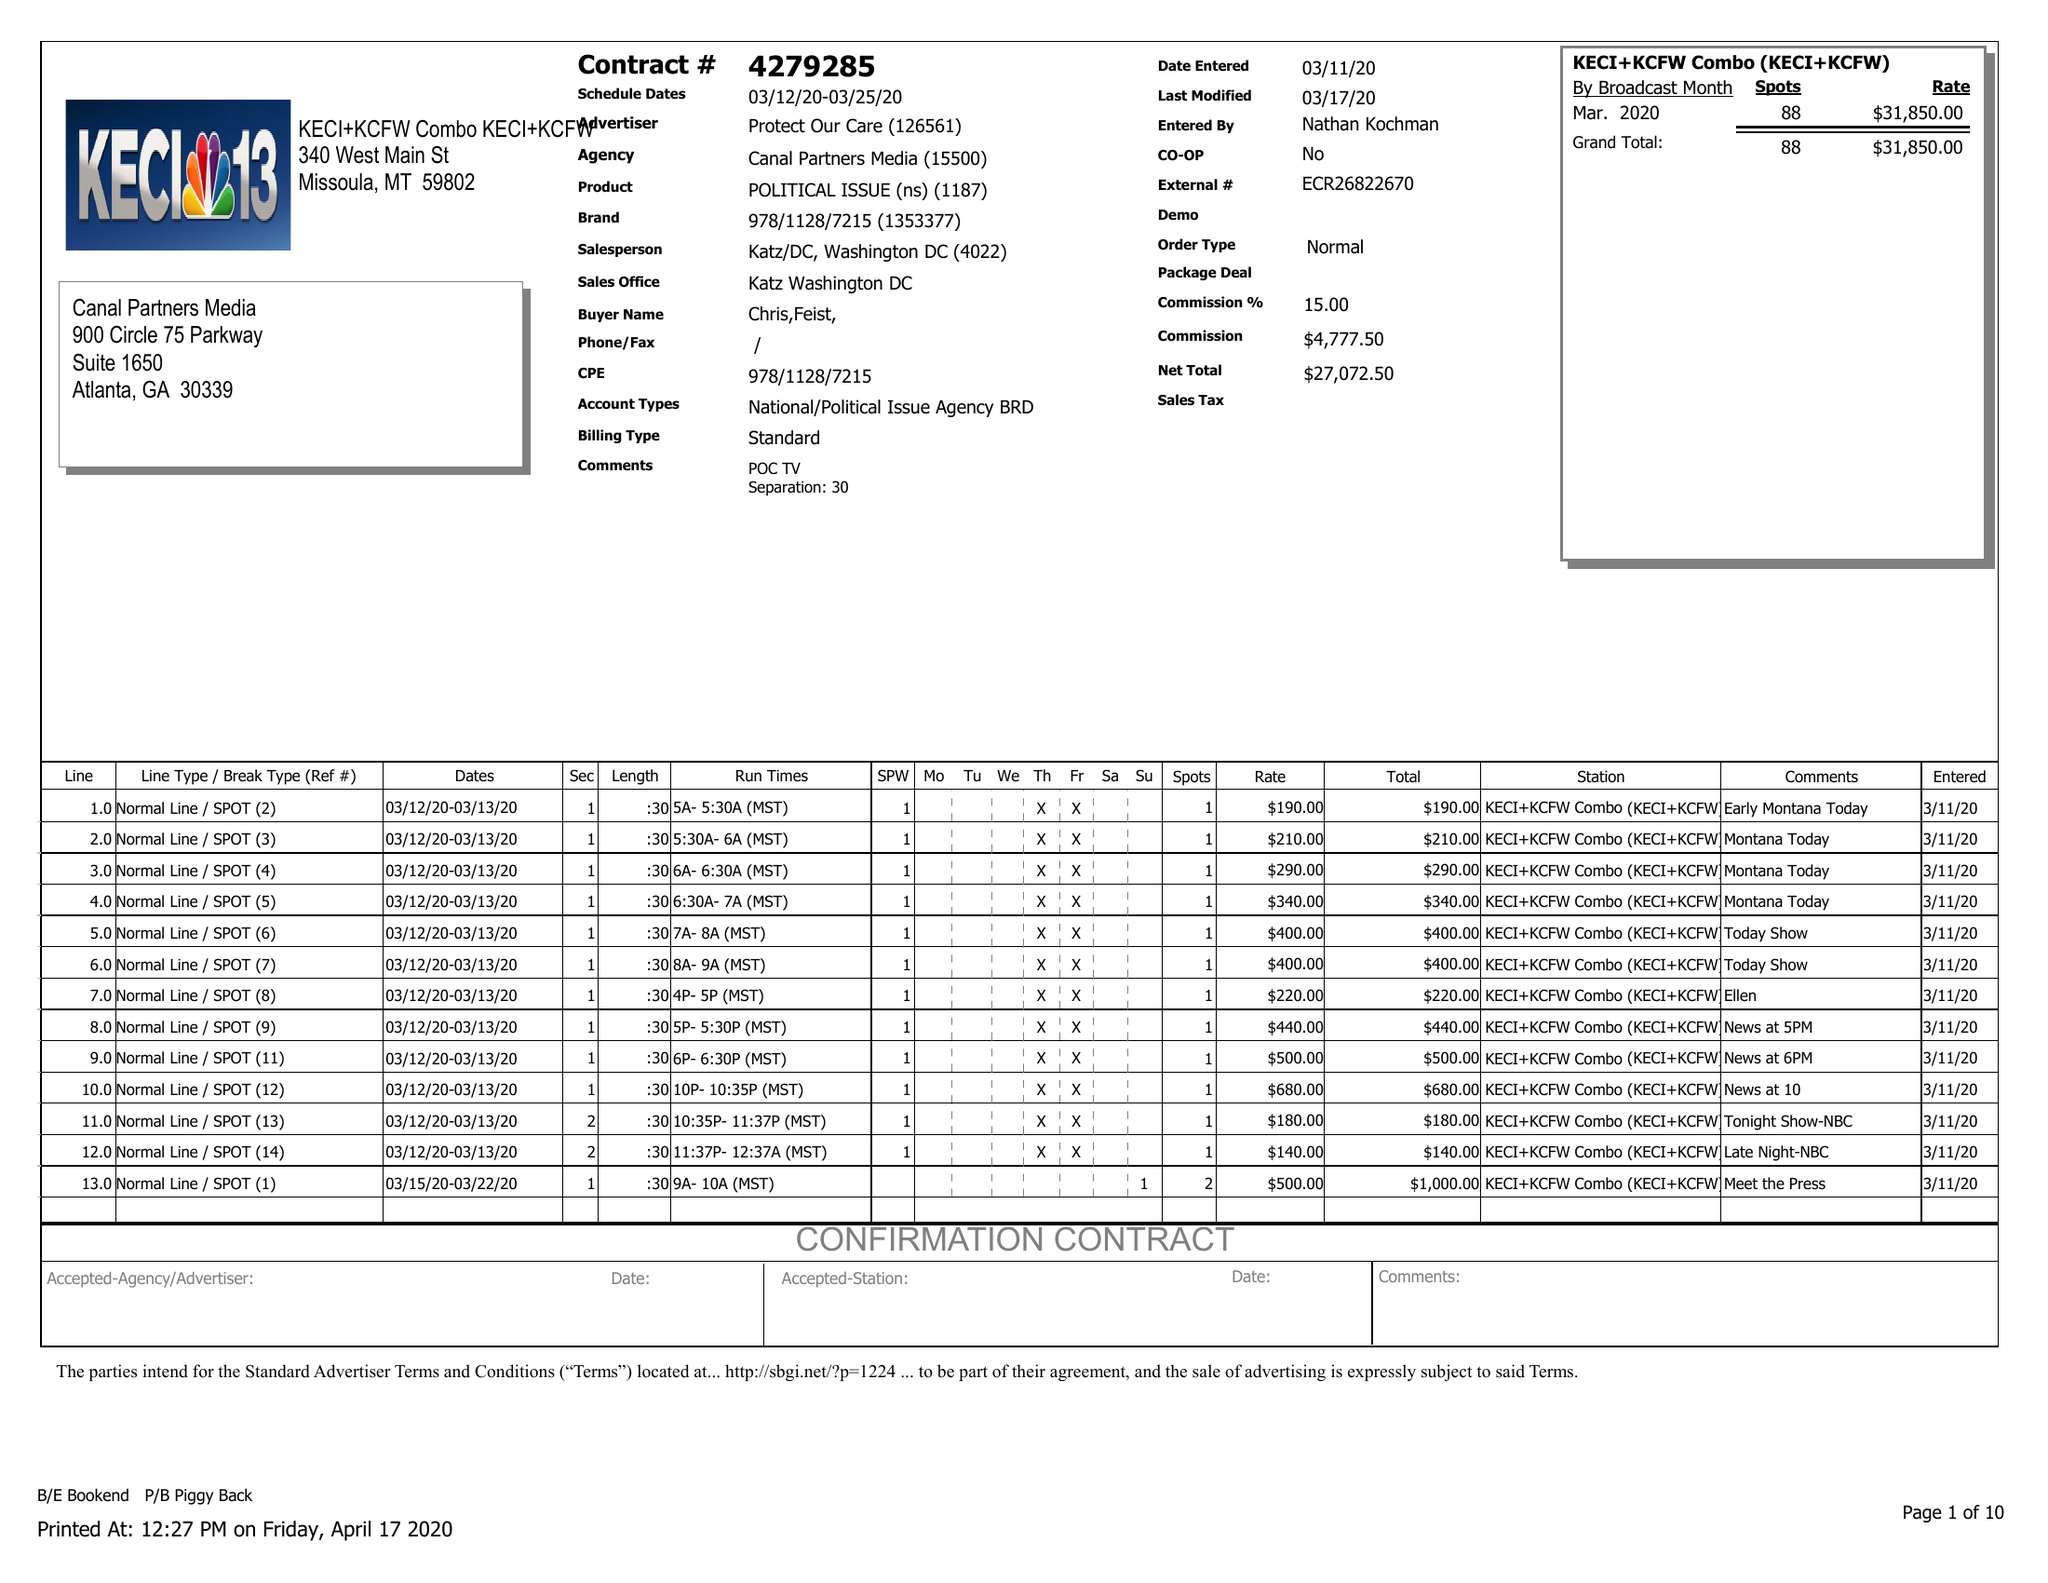What is the value for the gross_amount?
Answer the question using a single word or phrase. 31850.00 